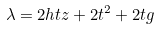Convert formula to latex. <formula><loc_0><loc_0><loc_500><loc_500>\lambda = 2 h t z + 2 t ^ { 2 } + 2 t g</formula> 